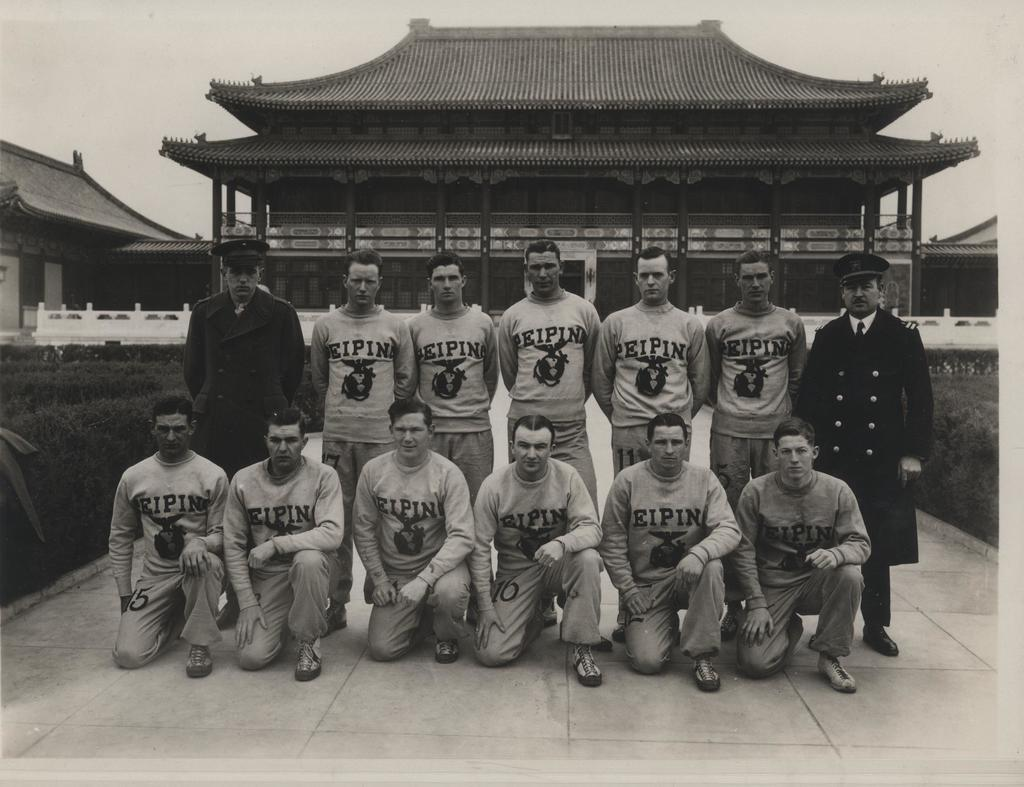<image>
Summarize the visual content of the image. A group of men wearing shirts that say Eipin are posing with two military men. 